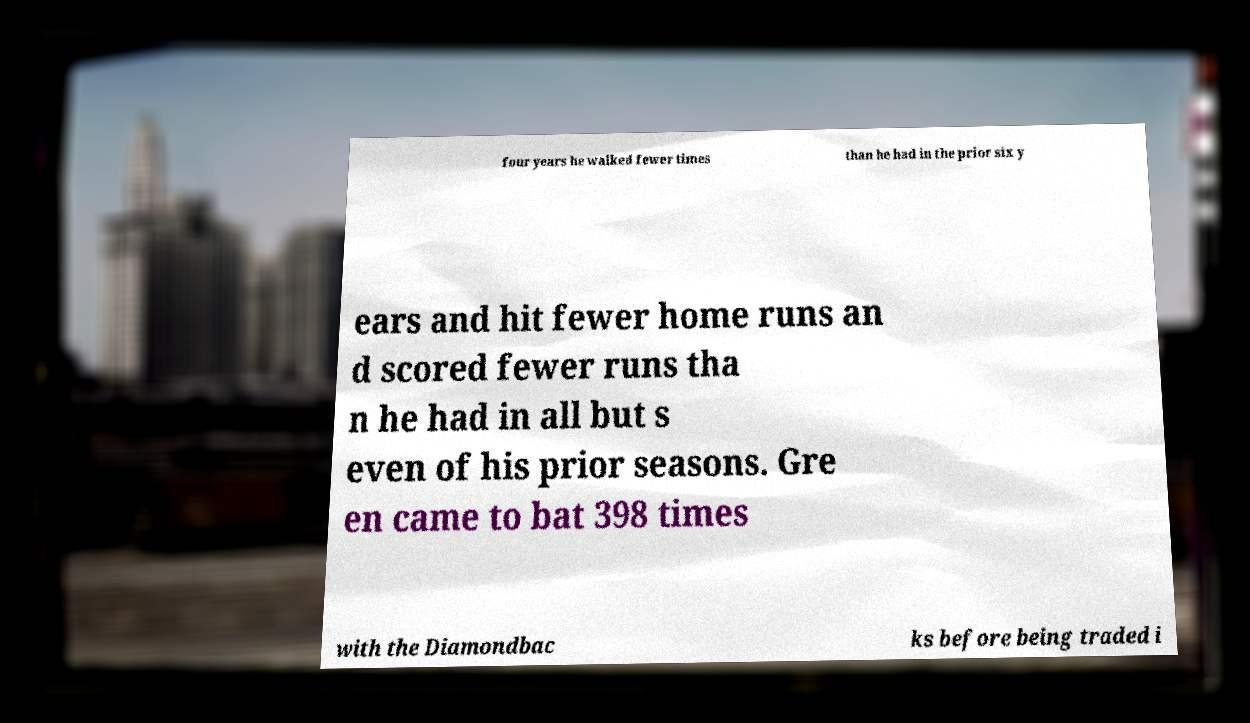Please read and relay the text visible in this image. What does it say? four years he walked fewer times than he had in the prior six y ears and hit fewer home runs an d scored fewer runs tha n he had in all but s even of his prior seasons. Gre en came to bat 398 times with the Diamondbac ks before being traded i 